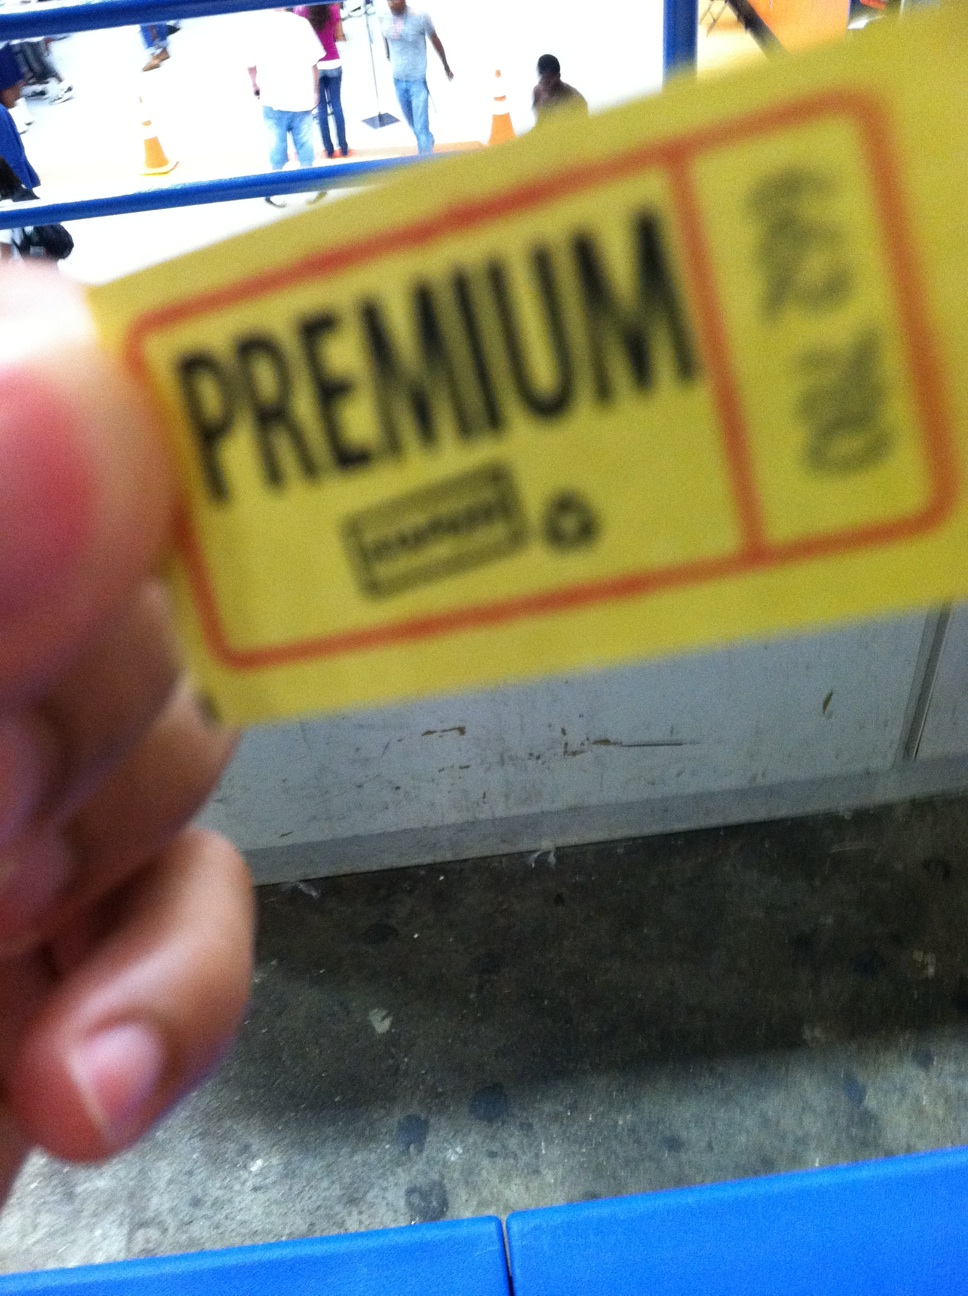Is there any text or symbols on the ticket that can provide more context? Aside from the prominent 'PREMIUM' text, there seems to be a small symbol or logo to the left and possible text underneath, which could indicate the issuing company or organization. The blurred image makes it challenging to provide more specific details without additional clarity. 